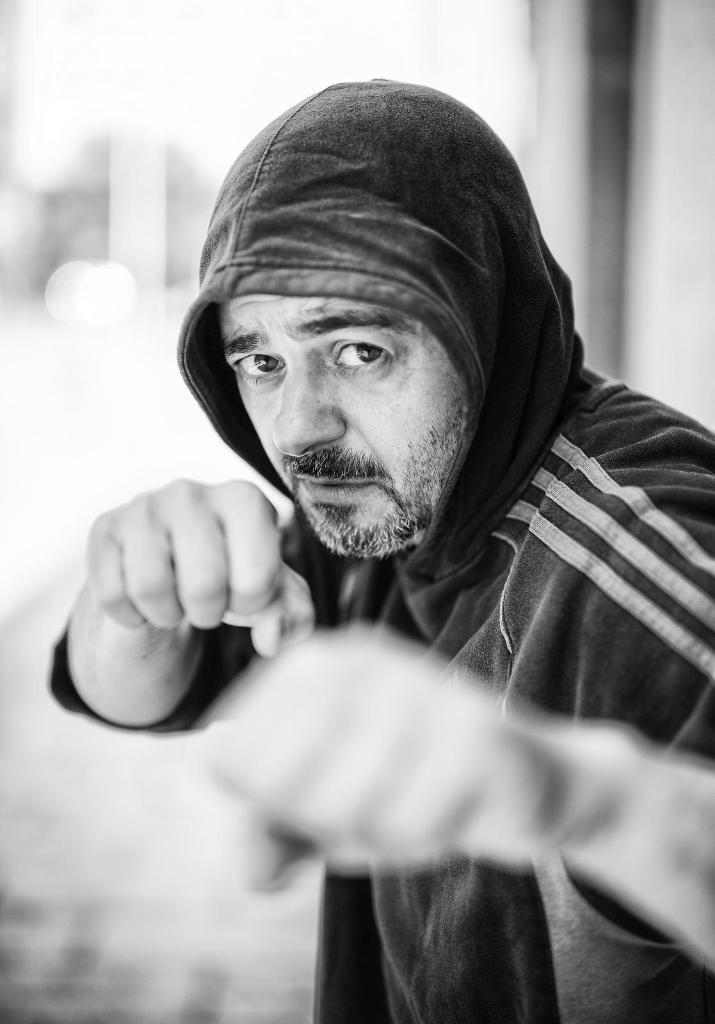What is the color scheme of the image? The image is black and white. Can you describe the main subject in the image? There is a person standing in the image. How would you describe the background of the image? The background appears blurry. What type of key is being used by the expert in the image? There is no expert or key present in the image; it features a person standing in a blurry background. 